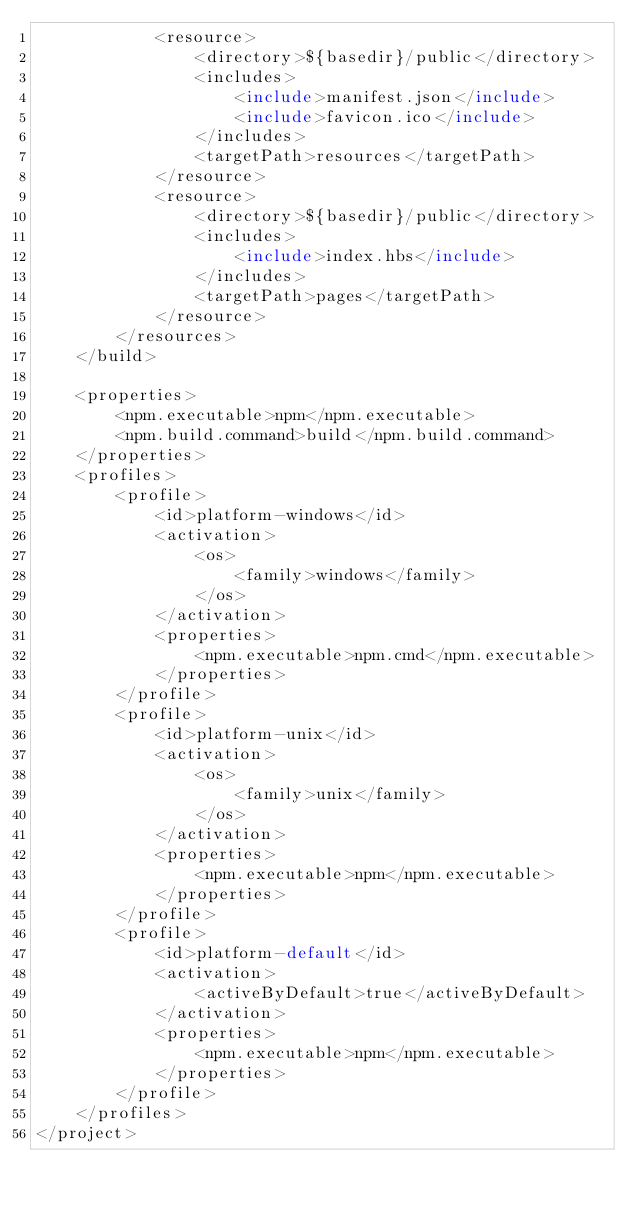Convert code to text. <code><loc_0><loc_0><loc_500><loc_500><_XML_>            <resource>
                <directory>${basedir}/public</directory>
                <includes>
                    <include>manifest.json</include>
                    <include>favicon.ico</include>
                </includes>
                <targetPath>resources</targetPath>
            </resource>
            <resource>
                <directory>${basedir}/public</directory>
                <includes>
                    <include>index.hbs</include>
                </includes>
                <targetPath>pages</targetPath>
            </resource>
        </resources>
    </build>

    <properties>
        <npm.executable>npm</npm.executable>
        <npm.build.command>build</npm.build.command>
    </properties>
    <profiles>
        <profile>
            <id>platform-windows</id>
            <activation>
                <os>
                    <family>windows</family>
                </os>
            </activation>
            <properties>
                <npm.executable>npm.cmd</npm.executable>
            </properties>
        </profile>
        <profile>
            <id>platform-unix</id>
            <activation>
                <os>
                    <family>unix</family>
                </os>
            </activation>
            <properties>
                <npm.executable>npm</npm.executable>
            </properties>
        </profile>
        <profile>
            <id>platform-default</id>
            <activation>
                <activeByDefault>true</activeByDefault>
            </activation>
            <properties>
                <npm.executable>npm</npm.executable>
            </properties>
        </profile>
    </profiles>
</project>
</code> 